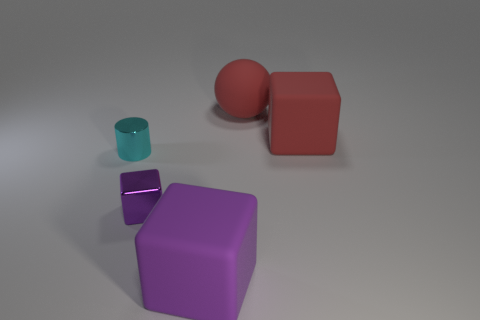The large rubber object that is the same color as the tiny metallic block is what shape?
Keep it short and to the point. Cube. There is a object that is to the right of the red sphere; does it have the same size as the big purple block?
Your answer should be compact. Yes. What number of other objects are the same size as the metal cylinder?
Offer a very short reply. 1. Are any large purple objects visible?
Make the answer very short. Yes. There is a rubber block that is behind the large matte object in front of the tiny cyan cylinder; what size is it?
Give a very brief answer. Large. There is a matte block that is right of the big purple matte block; is its color the same as the large matte cube that is to the left of the big red ball?
Ensure brevity in your answer.  No. There is a block that is both in front of the small cylinder and behind the big purple matte object; what is its color?
Offer a terse response. Purple. How many other things are there of the same shape as the tiny cyan object?
Your answer should be very brief. 0. There is a metal thing that is the same size as the cyan cylinder; what color is it?
Make the answer very short. Purple. The large thing to the left of the sphere is what color?
Offer a terse response. Purple. 